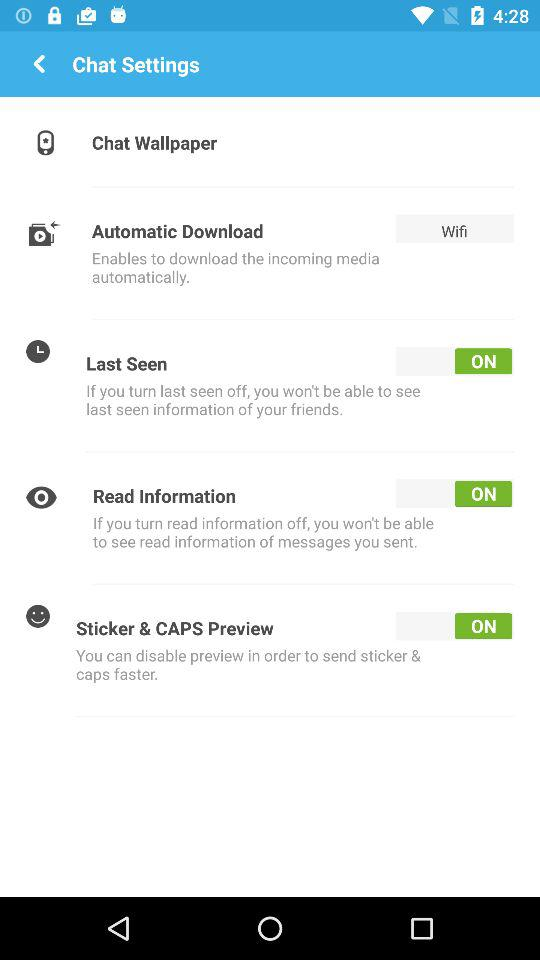How many items have a switch?
Answer the question using a single word or phrase. 3 